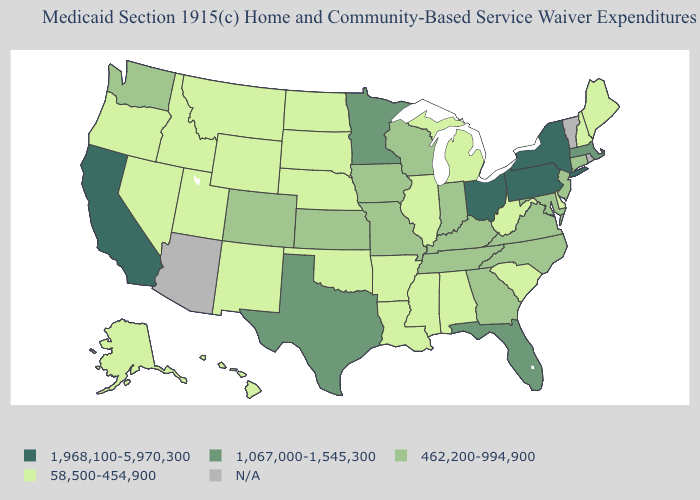What is the highest value in the South ?
Short answer required. 1,067,000-1,545,300. Name the states that have a value in the range 1,968,100-5,970,300?
Answer briefly. California, New York, Ohio, Pennsylvania. What is the value of New Jersey?
Be succinct. 462,200-994,900. Name the states that have a value in the range 58,500-454,900?
Quick response, please. Alabama, Alaska, Arkansas, Delaware, Hawaii, Idaho, Illinois, Louisiana, Maine, Michigan, Mississippi, Montana, Nebraska, Nevada, New Hampshire, New Mexico, North Dakota, Oklahoma, Oregon, South Carolina, South Dakota, Utah, West Virginia, Wyoming. Does New Mexico have the highest value in the West?
Give a very brief answer. No. Does the map have missing data?
Short answer required. Yes. Does Georgia have the highest value in the USA?
Write a very short answer. No. Is the legend a continuous bar?
Be succinct. No. Name the states that have a value in the range 1,067,000-1,545,300?
Concise answer only. Florida, Massachusetts, Minnesota, Texas. Does the map have missing data?
Keep it brief. Yes. What is the highest value in the USA?
Concise answer only. 1,968,100-5,970,300. What is the value of Indiana?
Concise answer only. 462,200-994,900. Name the states that have a value in the range 1,067,000-1,545,300?
Write a very short answer. Florida, Massachusetts, Minnesota, Texas. What is the value of Alaska?
Give a very brief answer. 58,500-454,900. 